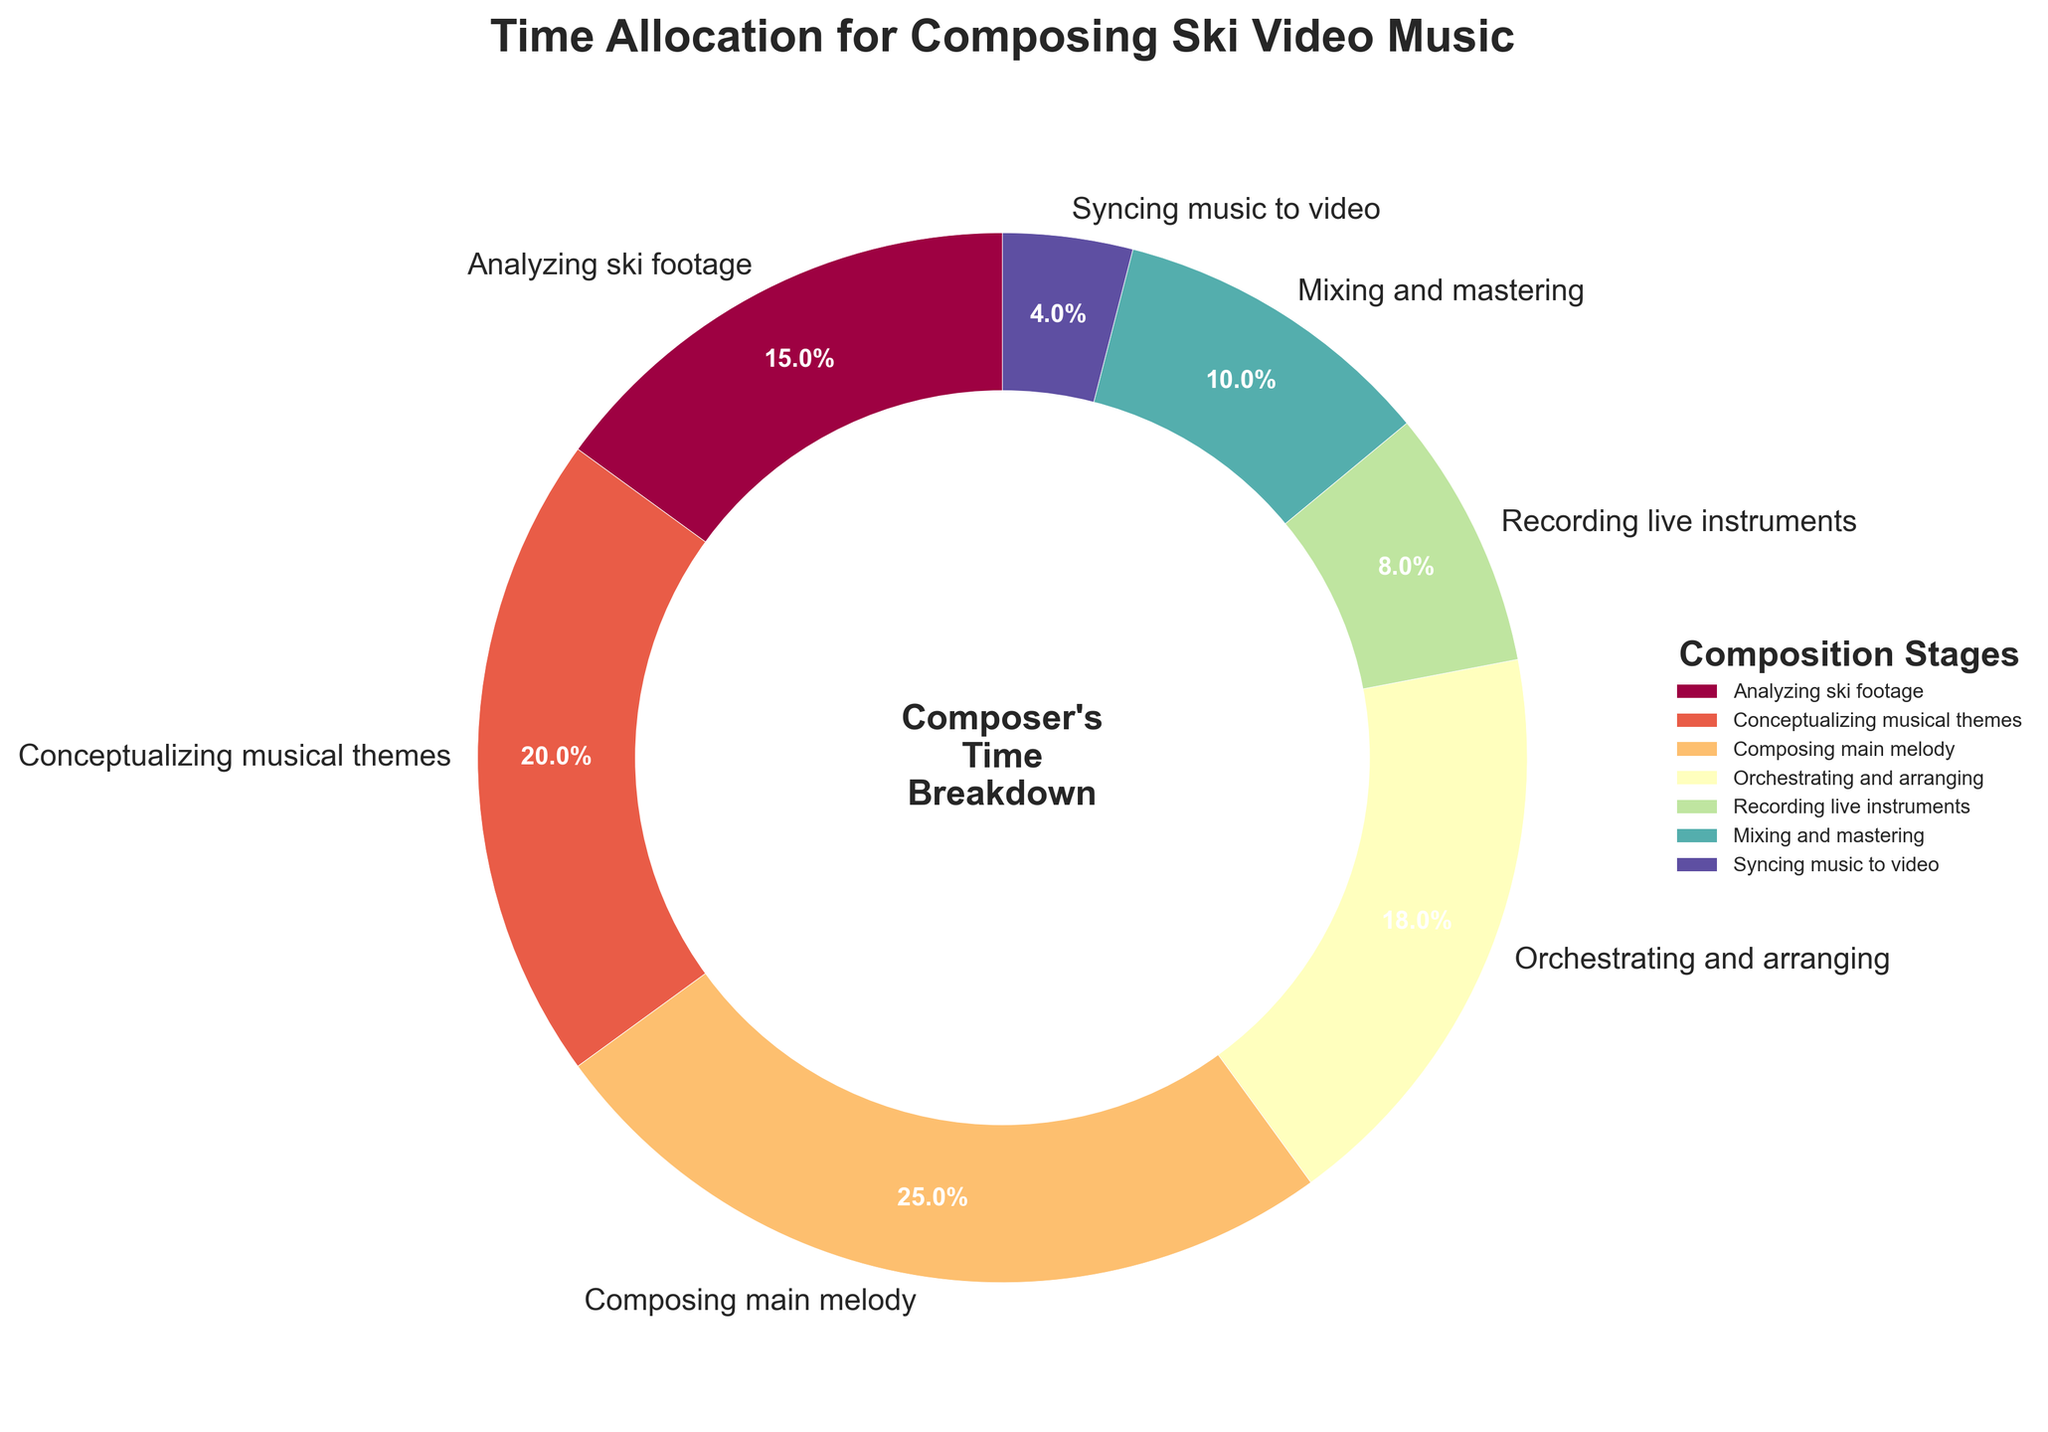What is the sum of the time spent on analyzing ski footage and composing the main melody? To find the sum of time spent on analyzing ski footage and composing the main melody, add their percentages together. Analyzing ski footage is 15%, and composing the main melody is 25%. Therefore, 15% + 25% = 40%.
Answer: 40% Which stage requires more time: mixing and mastering or recording live instruments? To determine which stage requires more time, compare their percentages. Mixing and mastering is 10%, while recording live instruments is 8%. Since 10% is greater than 8%, mixing and mastering requires more time.
Answer: Mixing and mastering What is the difference in time allocation between orchestrating and arranging and syncing music to video? To find the difference, subtract the percentage for syncing music to video from the percentage for orchestrating and arranging. Orchestrating and arranging is 18%, and syncing music to video is 4%. Therefore, 18% - 4% = 14%.
Answer: 14% Which stage has the highest time allocation, and what is its percentage? To identify the stage with the highest time allocation, look for the largest percentage in the chart. Composing the main melody has the highest time allocation at 25%.
Answer: Composing the main melody, 25% How much time in total is spent on tasks related to live sound (recording live instruments and mixing and mastering)? Sum the percentages for recording live instruments and mixing and mastering. Recording live instruments is 8%, and mixing and mastering is 10%. Therefore, 8% + 10% = 18%.
Answer: 18% What percentage of time is spent on tasks other than composing the main melody and conceptualizing musical themes? First, sum the percentages for composing the main melody and conceptualizing musical themes: 25% + 20% = 45%. Then subtract this sum from 100% to get the percentage spent on other tasks: 100% - 45% = 55%.
Answer: 55% Is the time spent on conceptualizing musical themes more than the time spent on syncing music to video? If so, by how much? To find out, compare the percentages for conceptualizing musical themes and syncing music to video. Conceptualizing musical themes is 20%, while syncing music to video is 4%. The difference is 20% - 4% = 16%.
Answer: Yes, by 16% What is the median value of the time allocations across all stages? To find the median, sort the time allocations and find the middle value. The sorted percentages are 4%, 8%, 10%, 15%, 18%, 20%, 25%. The median is the fourth value, which is 15%.
Answer: 15% What is the total percentage of time spent on composing tasks (conceptualizing musical themes, composing main melody, and orchestrating and arranging)? To find the total, sum the percentages for the composing tasks. Conceptualizing musical themes is 20%, composing the main melody is 25%, and orchestrating and arranging is 18%. Therefore, 20% + 25% + 18% = 63%.
Answer: 63% If you were to double the time spent on syncing music to video, what would its new percentage be? The current percentage for syncing music to video is 4%. Doubling this time would result in 4% * 2 = 8%.
Answer: 8% 